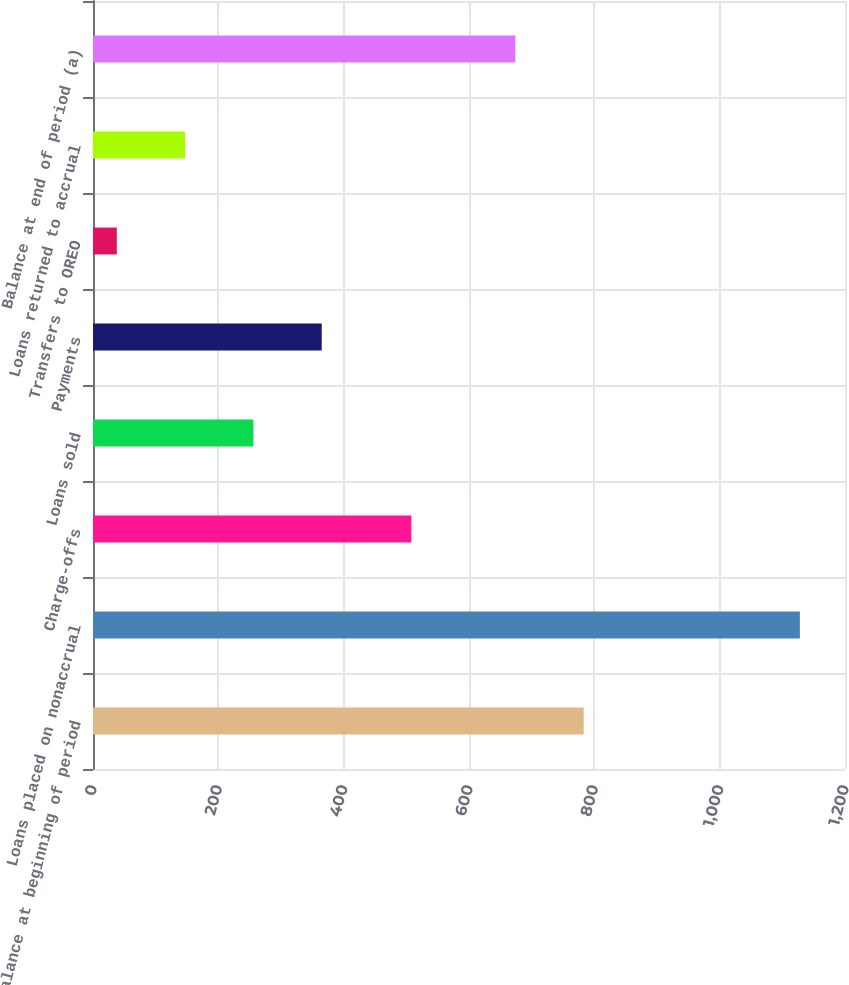Convert chart to OTSL. <chart><loc_0><loc_0><loc_500><loc_500><bar_chart><fcel>Balance at beginning of period<fcel>Loans placed on nonaccrual<fcel>Charge-offs<fcel>Loans sold<fcel>Payments<fcel>Transfers to OREO<fcel>Loans returned to accrual<fcel>Balance at end of period (a)<nl><fcel>783<fcel>1128<fcel>508<fcel>256<fcel>365<fcel>38<fcel>147<fcel>674<nl></chart> 